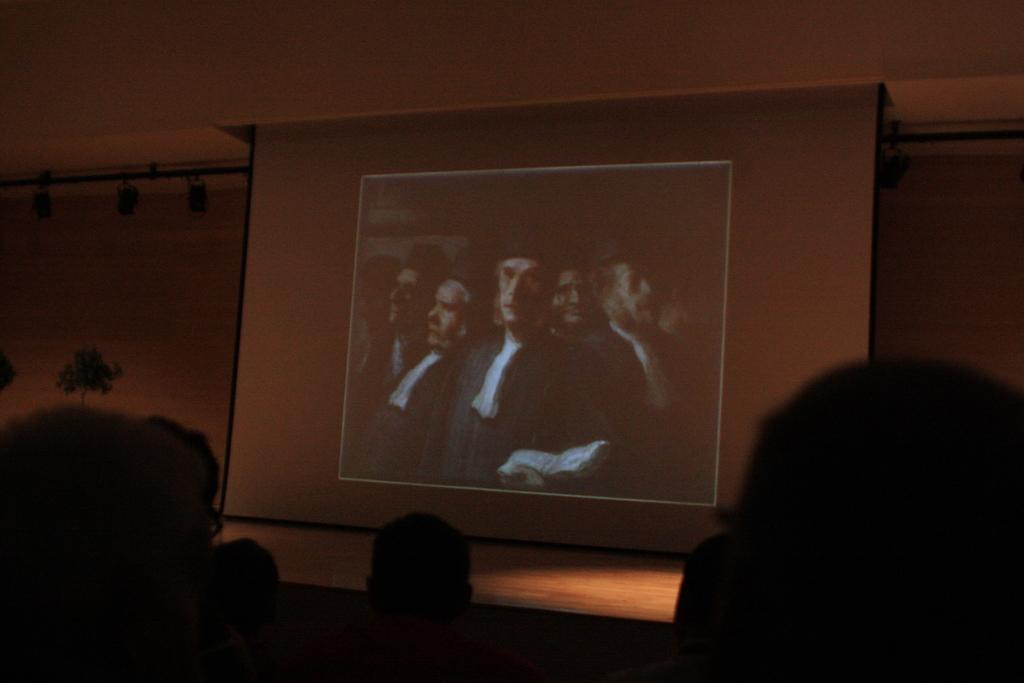Who is present in the image? There are people in the image. What are the people doing in the image? The people are sitting and watching a movie. How is the movie being displayed in the image? The movie is being displayed on a projector screen. How many apples are being eaten by the snail in the image? There is no snail or apple present in the image. What type of bean is growing on the projector screen in the image? There is no bean growing on the projector screen in the image. 